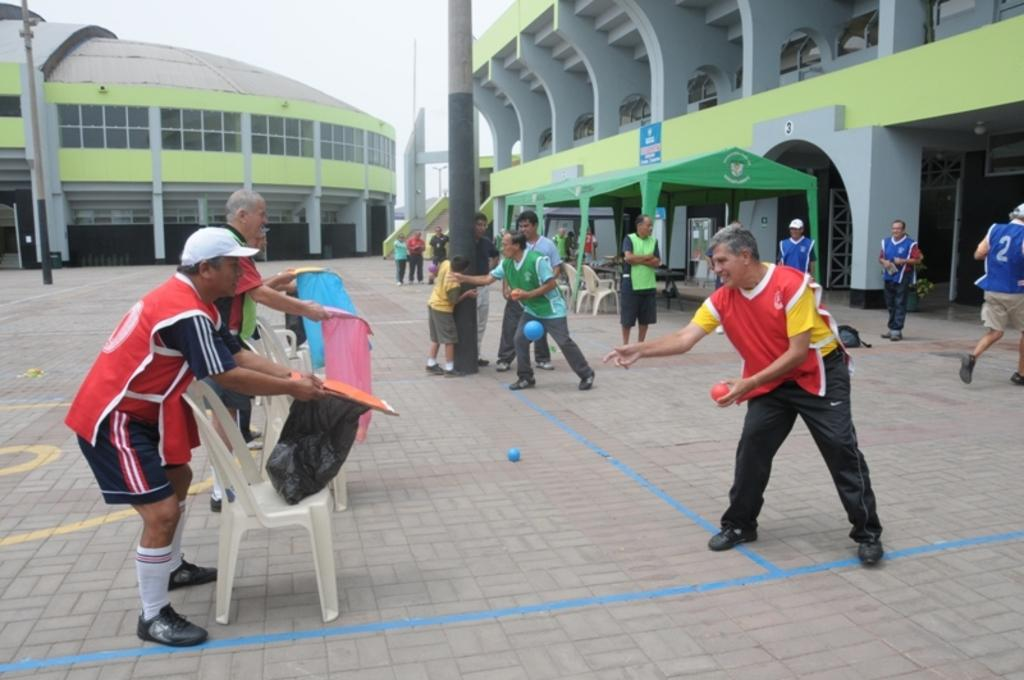How many buildings are visible in the image? There are two buildings in the image. What are the people on the right side of the image doing? The people are playing a game on the pavement. Which building is the game being played in front of? The game is being played in front of one of the buildings. What color is the tent behind the people? There is a green color tent behind the people. What type of screw is being used to hold the government building together in the image? There is no mention of a screw or a government building in the image. 